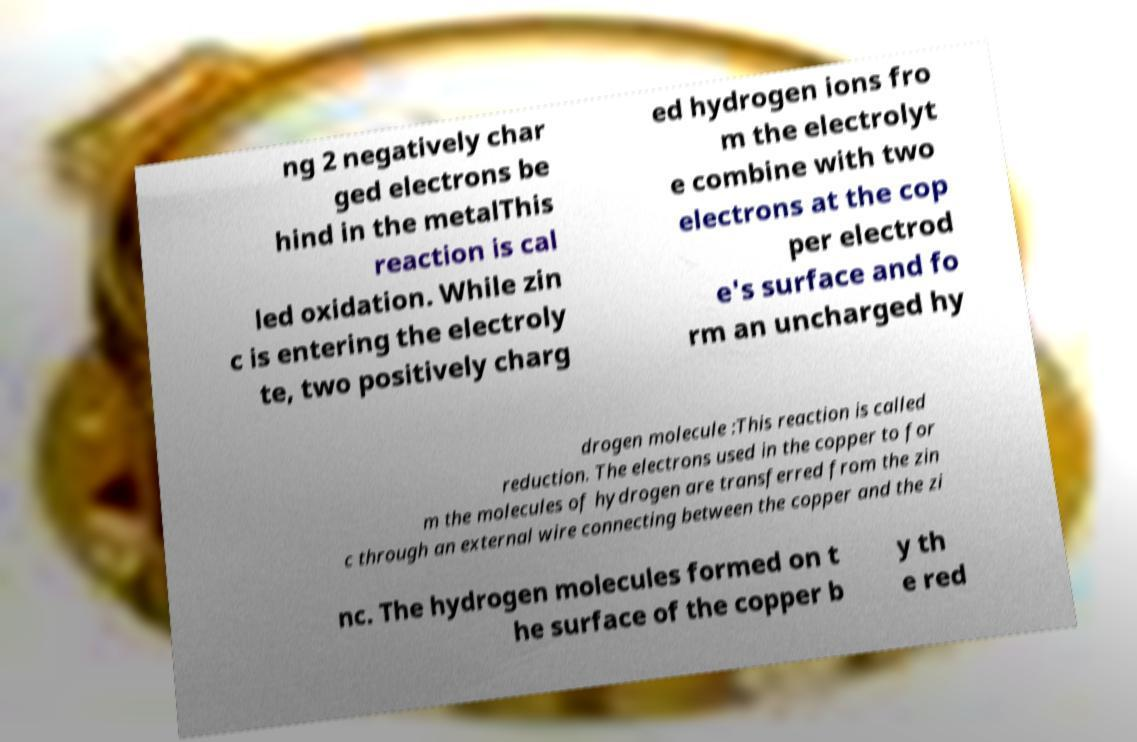Can you accurately transcribe the text from the provided image for me? ng 2 negatively char ged electrons be hind in the metalThis reaction is cal led oxidation. While zin c is entering the electroly te, two positively charg ed hydrogen ions fro m the electrolyt e combine with two electrons at the cop per electrod e's surface and fo rm an uncharged hy drogen molecule :This reaction is called reduction. The electrons used in the copper to for m the molecules of hydrogen are transferred from the zin c through an external wire connecting between the copper and the zi nc. The hydrogen molecules formed on t he surface of the copper b y th e red 